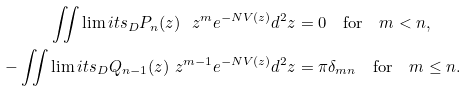Convert formula to latex. <formula><loc_0><loc_0><loc_500><loc_500>\iint \lim i t s _ { D } P _ { n } ( z ) \ z ^ { m } e ^ { - N V ( z ) } d ^ { 2 } z & = 0 \quad \text {for} \quad m < n , \\ - \iint \lim i t s _ { D } Q _ { n - 1 } ( z ) \ z ^ { m - 1 } e ^ { - N V ( z ) } d ^ { 2 } z & = \pi \delta _ { m n } \quad \text {for} \quad m \leq n .</formula> 